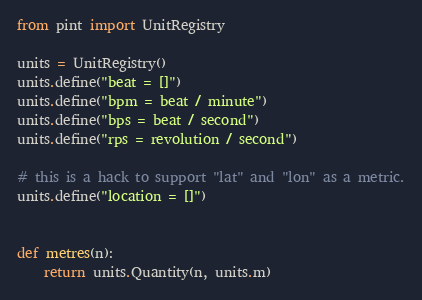<code> <loc_0><loc_0><loc_500><loc_500><_Python_>from pint import UnitRegistry

units = UnitRegistry()
units.define("beat = []")
units.define("bpm = beat / minute")
units.define("bps = beat / second")
units.define("rps = revolution / second")

# this is a hack to support "lat" and "lon" as a metric.
units.define("location = []")


def metres(n):
    return units.Quantity(n, units.m)
</code> 